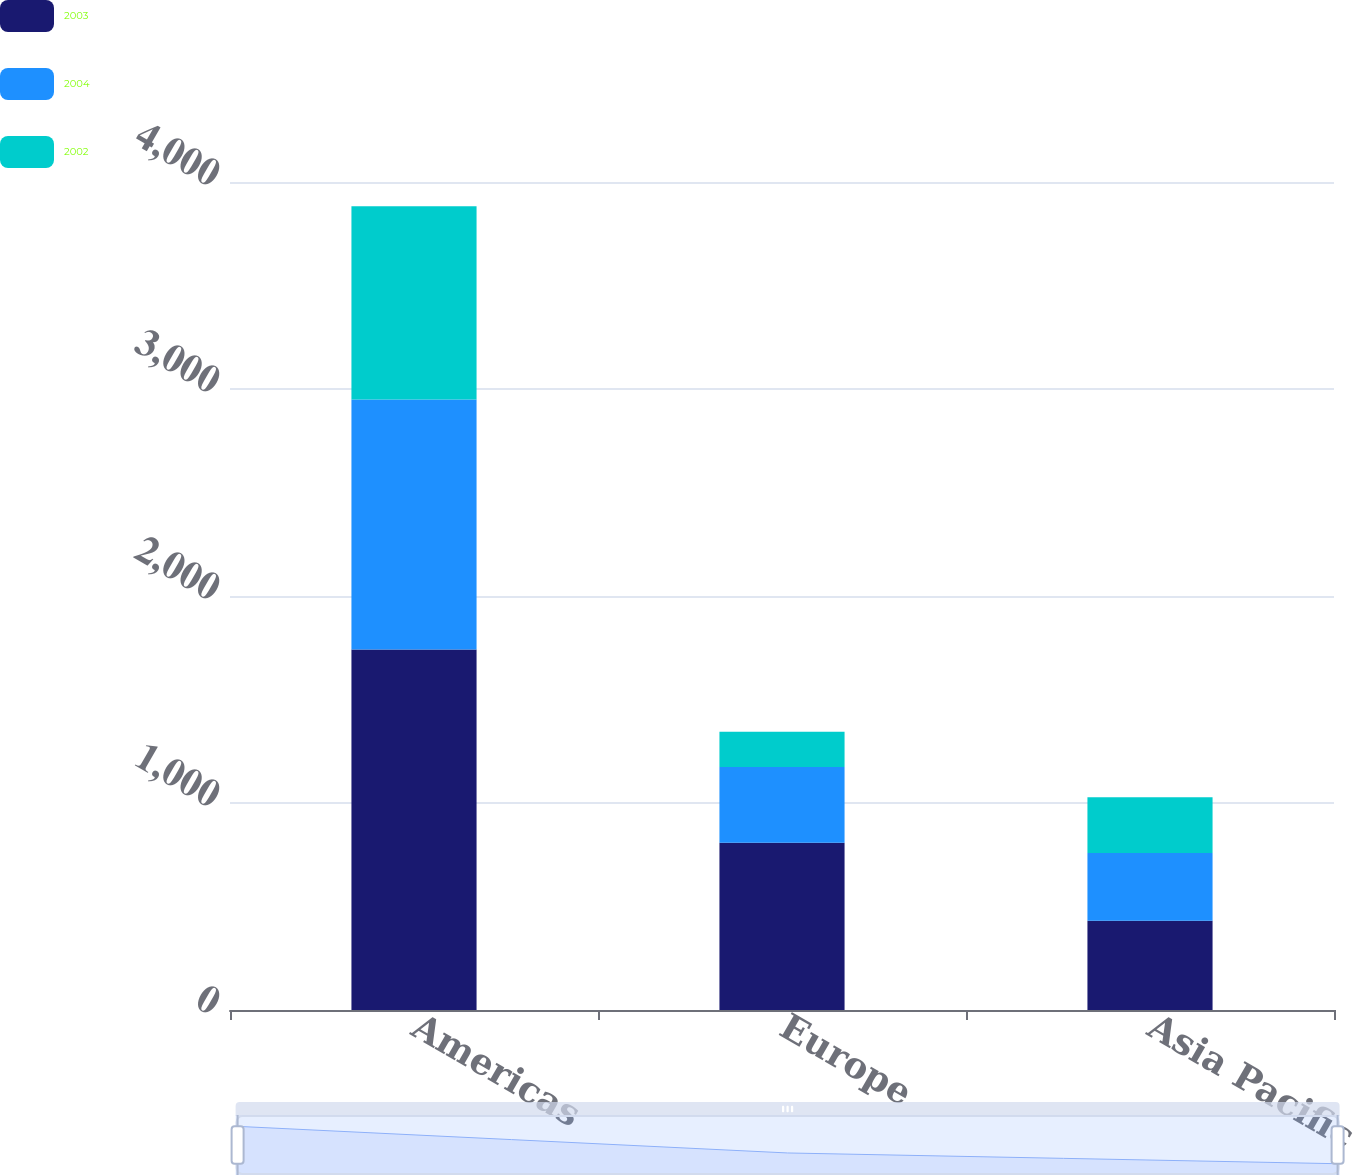Convert chart. <chart><loc_0><loc_0><loc_500><loc_500><stacked_bar_chart><ecel><fcel>Americas<fcel>Europe<fcel>Asia Pacific<nl><fcel>2003<fcel>1741.3<fcel>808.3<fcel>431.3<nl><fcel>2004<fcel>1208.3<fcel>366<fcel>326.7<nl><fcel>2002<fcel>932.9<fcel>169.9<fcel>269.6<nl></chart> 